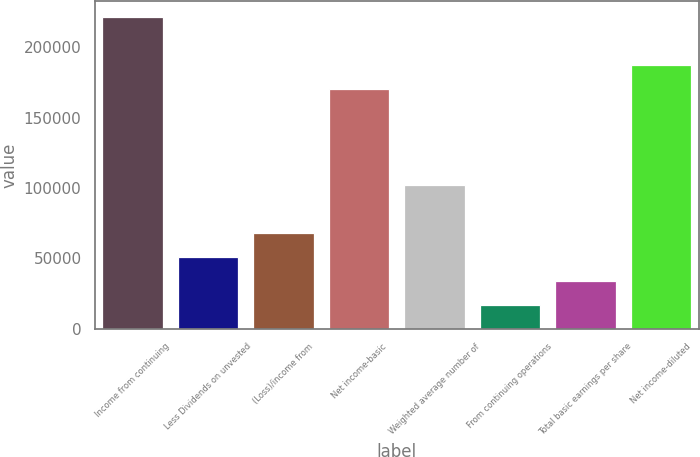Convert chart to OTSL. <chart><loc_0><loc_0><loc_500><loc_500><bar_chart><fcel>Income from continuing<fcel>Less Dividends on unvested<fcel>(Loss)/income from<fcel>Net income-basic<fcel>Weighted average number of<fcel>From continuing operations<fcel>Total basic earnings per share<fcel>Net income-diluted<nl><fcel>221463<fcel>51157.9<fcel>68209.5<fcel>170308<fcel>102313<fcel>17054.8<fcel>34106.3<fcel>187360<nl></chart> 